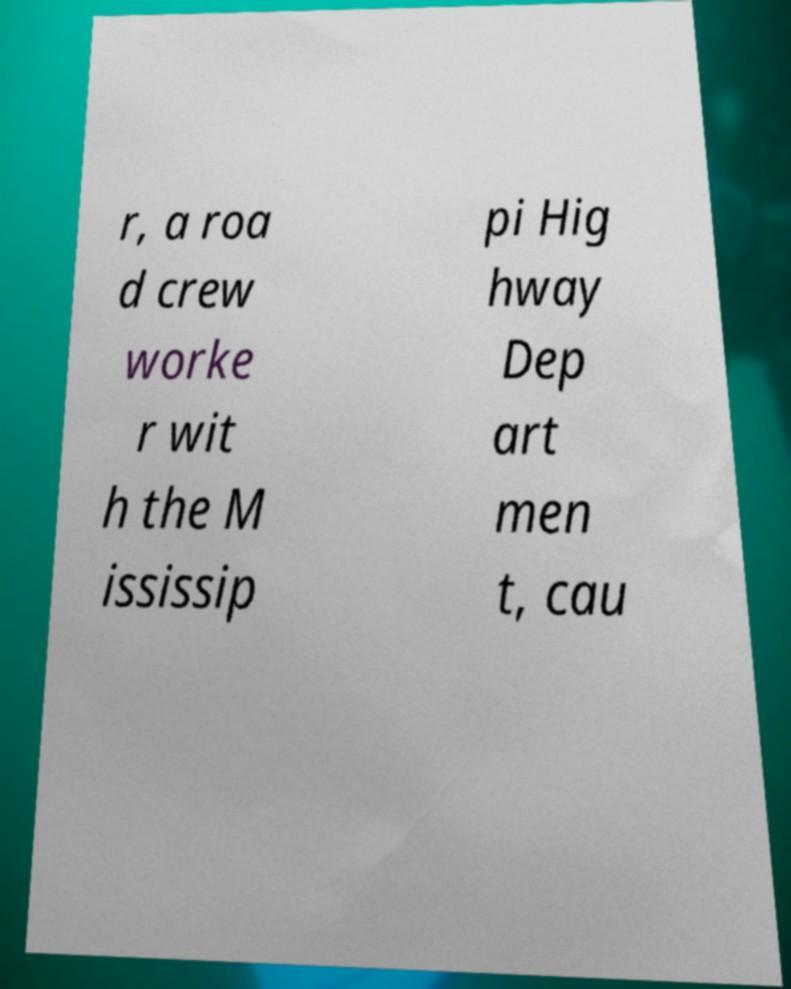There's text embedded in this image that I need extracted. Can you transcribe it verbatim? r, a roa d crew worke r wit h the M ississip pi Hig hway Dep art men t, cau 